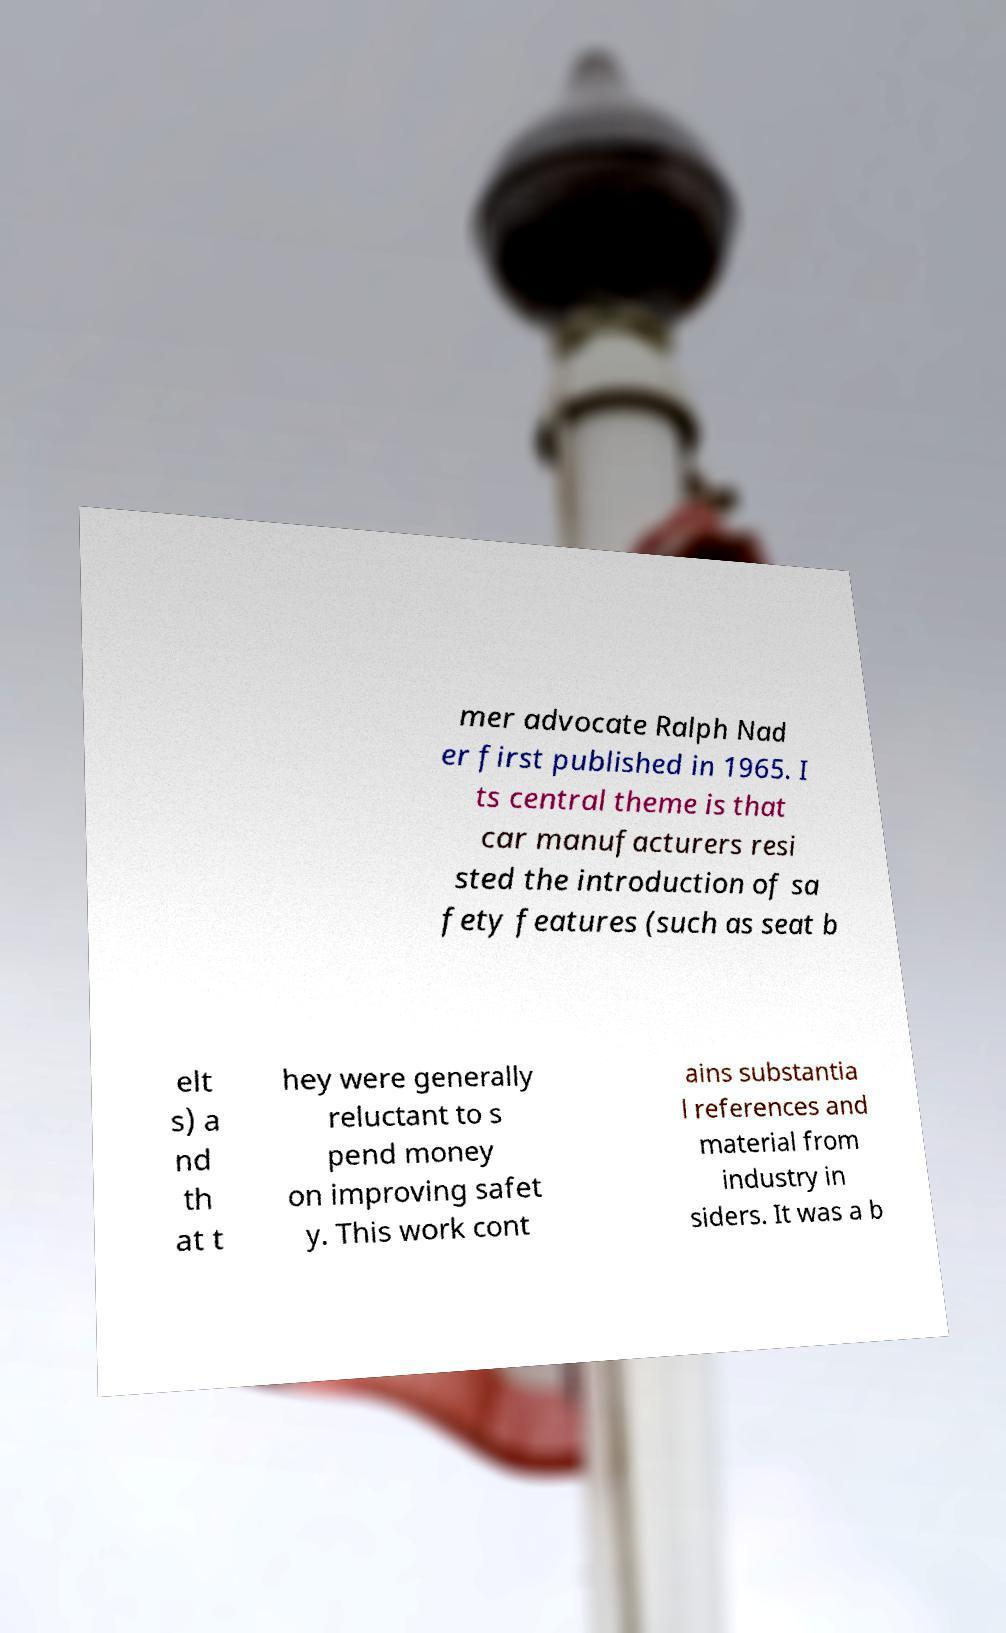What messages or text are displayed in this image? I need them in a readable, typed format. mer advocate Ralph Nad er first published in 1965. I ts central theme is that car manufacturers resi sted the introduction of sa fety features (such as seat b elt s) a nd th at t hey were generally reluctant to s pend money on improving safet y. This work cont ains substantia l references and material from industry in siders. It was a b 